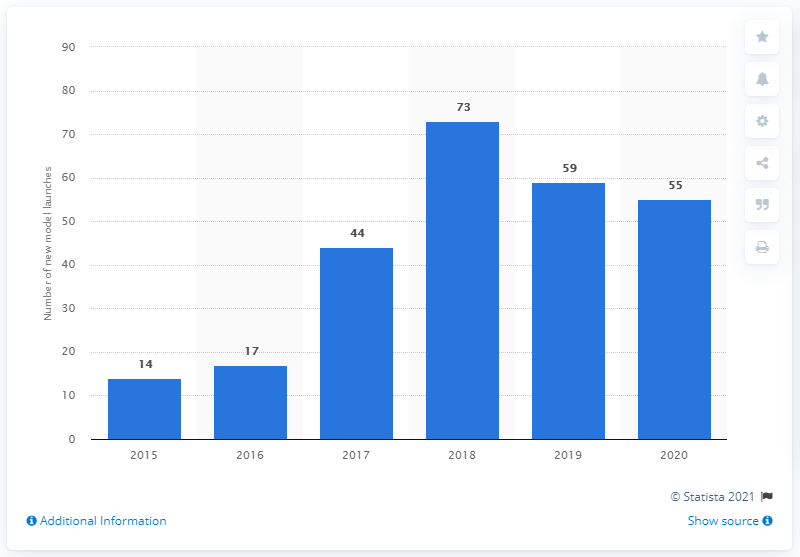Draw attention to some important aspects in this diagram. It is expected that 55 new battery electric vehicle models will be launched worldwide between 2015 and 2020. 